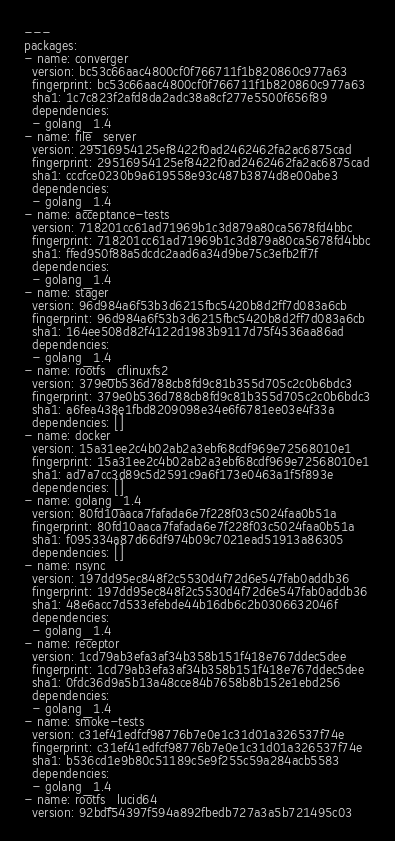Convert code to text. <code><loc_0><loc_0><loc_500><loc_500><_YAML_>---
packages:
- name: converger
  version: bc53c66aac4800cf0f766711f1b820860c977a63
  fingerprint: bc53c66aac4800cf0f766711f1b820860c977a63
  sha1: 1c7c823f2afd8da2adc38a8cf277e5500f656f89
  dependencies:
  - golang_1.4
- name: file_server
  version: 29516954125ef8422f0ad2462462fa2ac6875cad
  fingerprint: 29516954125ef8422f0ad2462462fa2ac6875cad
  sha1: cccfce0230b9a619558e93c487b3874d8e00abe3
  dependencies:
  - golang_1.4
- name: acceptance-tests
  version: 718201cc61ad71969b1c3d879a80ca5678fd4bbc
  fingerprint: 718201cc61ad71969b1c3d879a80ca5678fd4bbc
  sha1: ffed950f88a5dcdc2aad6a34d9be75c3efb2ff7f
  dependencies:
  - golang_1.4
- name: stager
  version: 96d984a6f53b3d6215fbc5420b8d2ff7d083a6cb
  fingerprint: 96d984a6f53b3d6215fbc5420b8d2ff7d083a6cb
  sha1: 164ee508d82f4122d1983b9117d75f4536aa86ad
  dependencies:
  - golang_1.4
- name: rootfs_cflinuxfs2
  version: 379e0b536d788cb8fd9c81b355d705c2c0b6bdc3
  fingerprint: 379e0b536d788cb8fd9c81b355d705c2c0b6bdc3
  sha1: a6fea438e1fbd8209098e34e6f6781ee03e4f33a
  dependencies: []
- name: docker
  version: 15a31ee2c4b02ab2a3ebf68cdf969e72568010e1
  fingerprint: 15a31ee2c4b02ab2a3ebf68cdf969e72568010e1
  sha1: ad7a7cc3d89c5d2591c9a6f173e0463a1f5f893e
  dependencies: []
- name: golang_1.4
  version: 80fd10aaca7fafada6e7f228f03c5024faa0b51a
  fingerprint: 80fd10aaca7fafada6e7f228f03c5024faa0b51a
  sha1: f095334a87d66df974b09c7021ead51913a86305
  dependencies: []
- name: nsync
  version: 197dd95ec848f2c5530d4f72d6e547fab0addb36
  fingerprint: 197dd95ec848f2c5530d4f72d6e547fab0addb36
  sha1: 48e6acc7d533efebde44b16db6c2b0306632046f
  dependencies:
  - golang_1.4
- name: receptor
  version: 1cd79ab3efa3af34b358b151f418e767ddec5dee
  fingerprint: 1cd79ab3efa3af34b358b151f418e767ddec5dee
  sha1: 0fdc36d9a5b13a48cce84b7658b8b152e1ebd256
  dependencies:
  - golang_1.4
- name: smoke-tests
  version: c31ef41edfcf98776b7e0e1c31d01a326537f74e
  fingerprint: c31ef41edfcf98776b7e0e1c31d01a326537f74e
  sha1: b536cd1e9b80c51189c5e9f255c59a284acb5583
  dependencies:
  - golang_1.4
- name: rootfs_lucid64
  version: 92bdf54397f594a892fbedb727a3a5b721495c03</code> 